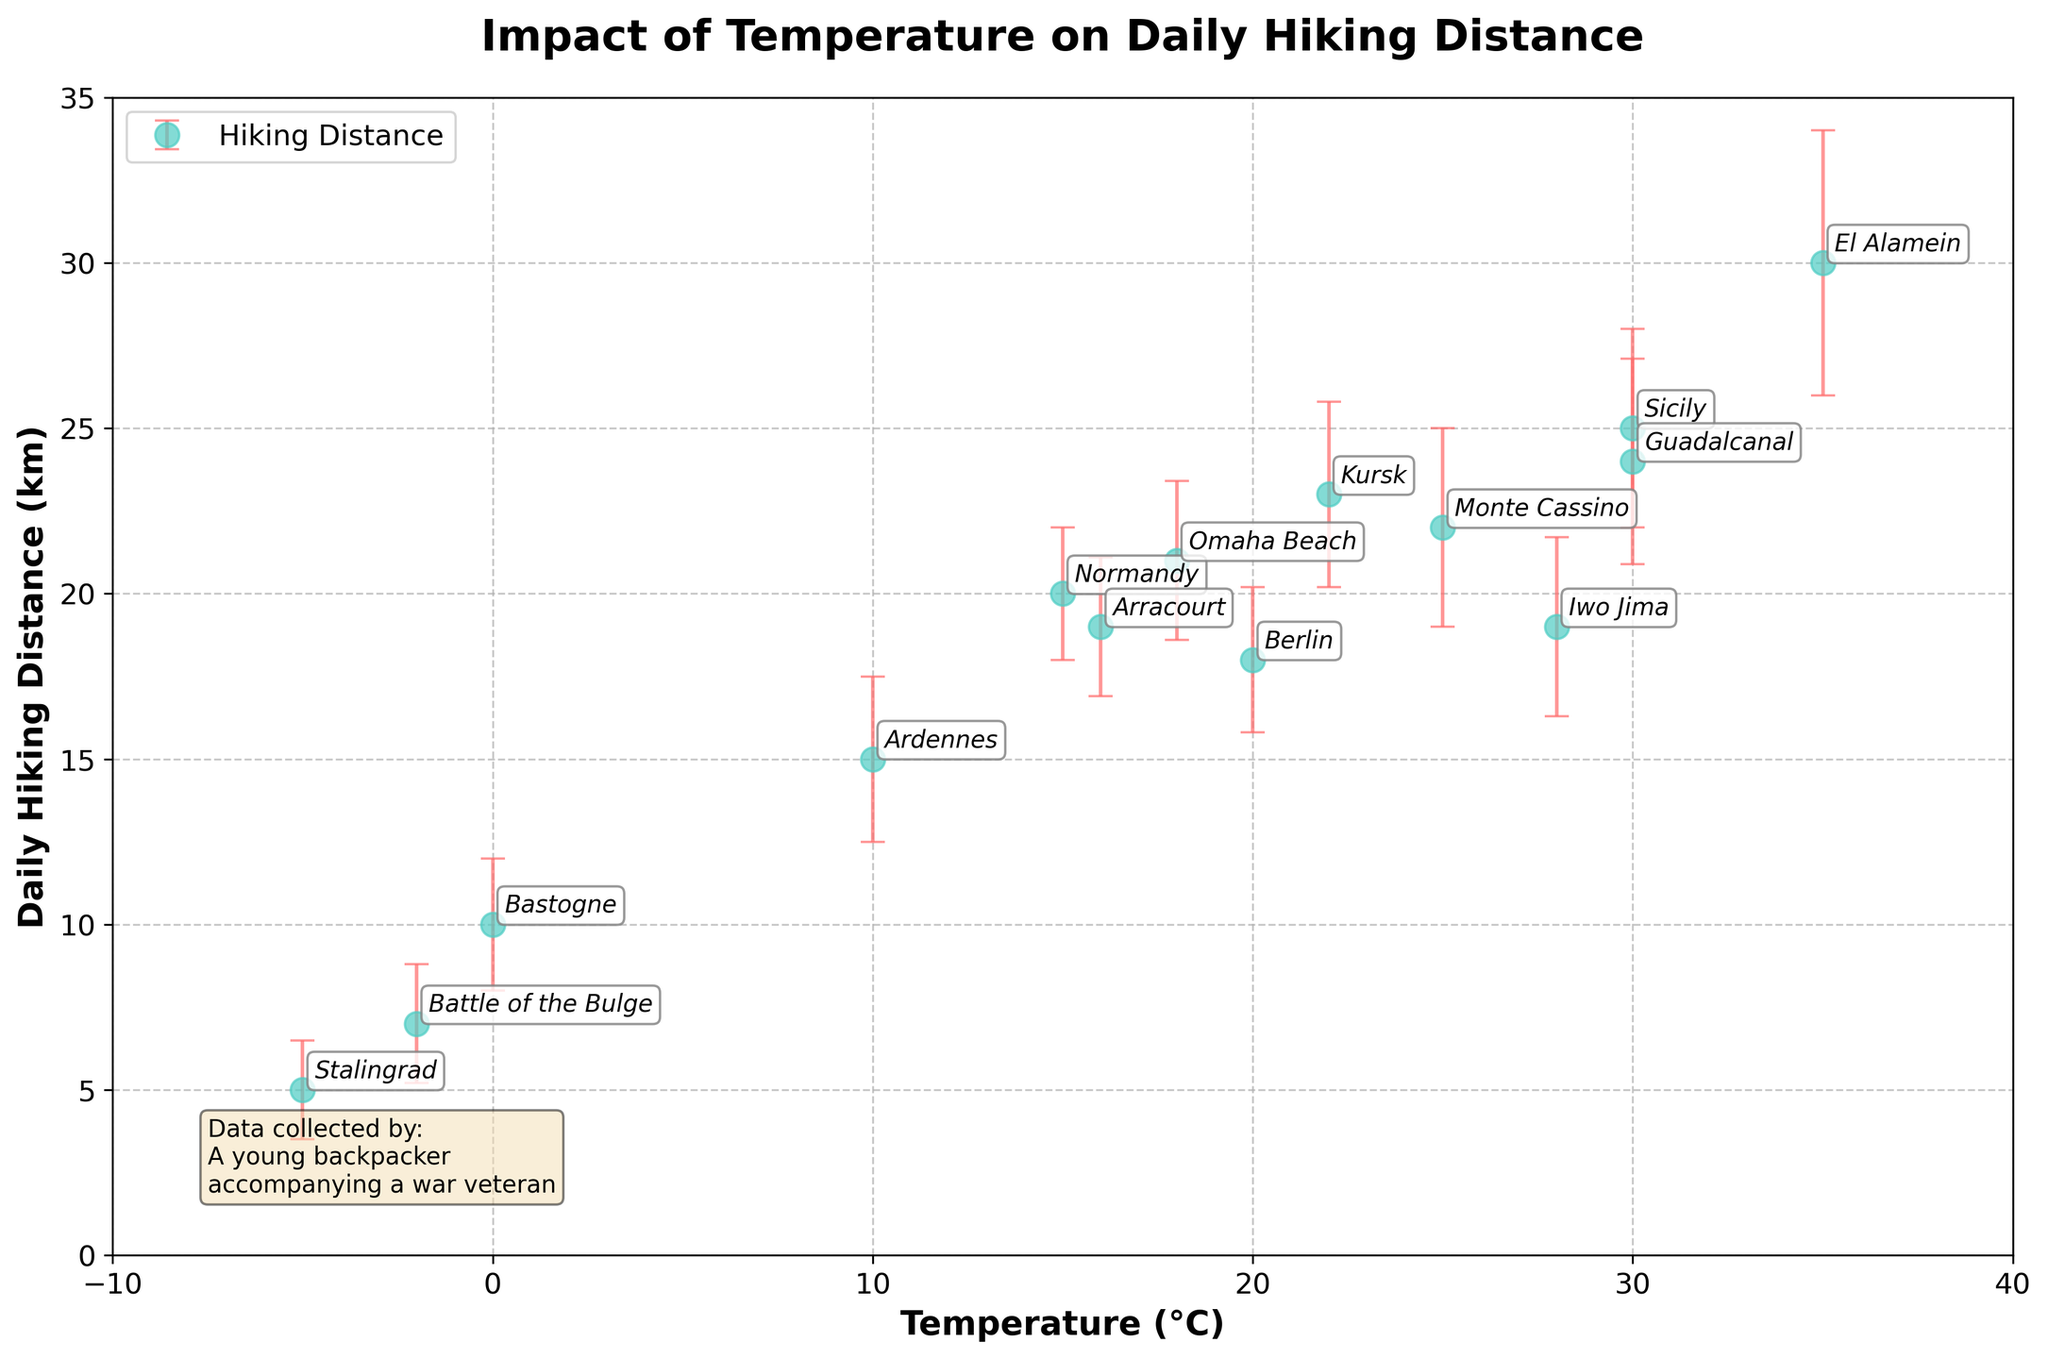What is the title of the figure? The title of the figure is displayed at the top in bold text. It reads "Impact of Temperature on Daily Hiking Distance".
Answer: Impact of Temperature on Daily Hiking Distance What are the labels for the x-axis and y-axis? The x-axis label is "Temperature (°C)" and the y-axis label is "Daily Hiking Distance (km)". This information is found directly adjacent to each axis.
Answer: Temperature (°C) and Daily Hiking Distance (km) How many data points are there in the plot? By counting the number of marked points in the scatter plot, we find that there are 14 data points, one for each location.
Answer: 14 Which location has the highest daily hiking distance? By examining the y-values of the data points and their corresponding labels, we can identify that the highest daily hiking distance is 30 km, marked by El Alamein.
Answer: El Alamein What is the daily hiking distance and error margin for Stalingrad? Locate the Stalingrad point on the plot. The y-axis value for Stalingrad is 5 km, and the error margin is indicated by the height of the error bar, which is 1.5 km.
Answer: 5 km and 1.5 km What is the average daily hiking distance across all locations? Sum the daily hiking distances for all locations: (20 + 15 + 25 + 5 + 30 + 10 + 18 + 22 + 19 + 21 + 7 + 24 + 23 + 19) = 258 km. There are 14 locations, so the average distance is 258 km / 14 = 18.43 km.
Answer: 18.43 km Compare the daily hiking distances between Omaha Beach and Guadalcanal. Which one is higher and by how much? Omaha Beach has a daily hiking distance of 21 km and Guadalcanal has 24 km. 24 km - 21 km = 3 km. Thus, Guadalcanal is higher by 3 km.
Answer: Guadalcanal by 3 km Which locations have a daily hiking distance within the error margin overlapping the average daily hiking distance? Calculate the average daily hiking distance, which is 18.43 km. Identify locations where the error bars (distance ± error) intersect this average: Normandy (18 to 22), Berlin (15.8 to 20.2), Monte Cassino (19 to 25), Iwo Jima (16.3 to 21.7), Kursk (20.2 to 25.8), and Arracourt (16.9 to 21.1) all overlap with 18.43 km.
Answer: Normandy, Berlin, Monte Cassino, Iwo Jima, Kursk, Arracourt Which two locations have the closest daily hiking distances? Compare the daily hiking distances and identify the closest pair: Arracourt (19 km) and Iwo Jima (19 km), as they both share the same daily hiking distance.
Answer: Arracourt and Iwo Jima What is the relationship between temperature and daily hiking distance? Observe the trend from the scatter plot. Locations with moderate temperatures (e.g., Sicily, Monte Cassino, Kursk, Berlin) generally show higher hiking distances, whereas extreme temperatures (e.g., Stalingrad, Battle of the Bulge) show lower distances. This suggests that moderate temperatures are generally more conducive to longer hiking distances.
Answer: Moderate temperatures are more conducive to longer hiking distances 